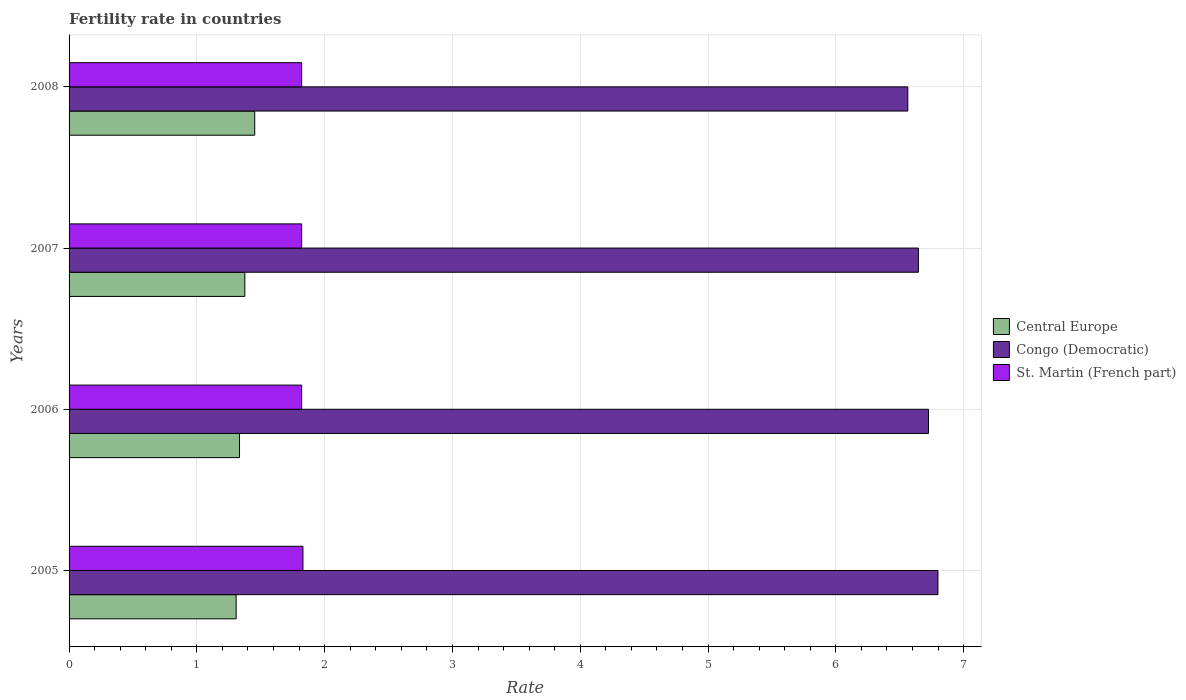How many different coloured bars are there?
Give a very brief answer. 3. How many groups of bars are there?
Provide a succinct answer. 4. Are the number of bars per tick equal to the number of legend labels?
Keep it short and to the point. Yes. How many bars are there on the 2nd tick from the top?
Offer a very short reply. 3. What is the label of the 3rd group of bars from the top?
Offer a terse response. 2006. What is the fertility rate in St. Martin (French part) in 2008?
Your answer should be compact. 1.82. Across all years, what is the maximum fertility rate in St. Martin (French part)?
Your answer should be very brief. 1.83. Across all years, what is the minimum fertility rate in St. Martin (French part)?
Your answer should be compact. 1.82. What is the total fertility rate in Central Europe in the graph?
Offer a very short reply. 5.47. What is the difference between the fertility rate in Congo (Democratic) in 2007 and that in 2008?
Ensure brevity in your answer.  0.08. What is the difference between the fertility rate in Central Europe in 2006 and the fertility rate in Congo (Democratic) in 2008?
Offer a terse response. -5.23. What is the average fertility rate in Congo (Democratic) per year?
Keep it short and to the point. 6.68. In the year 2006, what is the difference between the fertility rate in Congo (Democratic) and fertility rate in Central Europe?
Give a very brief answer. 5.39. In how many years, is the fertility rate in St. Martin (French part) greater than 0.2 ?
Offer a very short reply. 4. What is the difference between the highest and the second highest fertility rate in St. Martin (French part)?
Provide a short and direct response. 0.01. What is the difference between the highest and the lowest fertility rate in Congo (Democratic)?
Keep it short and to the point. 0.24. In how many years, is the fertility rate in Central Europe greater than the average fertility rate in Central Europe taken over all years?
Provide a succinct answer. 2. What does the 3rd bar from the top in 2007 represents?
Keep it short and to the point. Central Europe. What does the 3rd bar from the bottom in 2005 represents?
Your answer should be very brief. St. Martin (French part). Is it the case that in every year, the sum of the fertility rate in St. Martin (French part) and fertility rate in Central Europe is greater than the fertility rate in Congo (Democratic)?
Your answer should be very brief. No. How many bars are there?
Offer a very short reply. 12. How many years are there in the graph?
Give a very brief answer. 4. Where does the legend appear in the graph?
Provide a succinct answer. Center right. What is the title of the graph?
Give a very brief answer. Fertility rate in countries. What is the label or title of the X-axis?
Your answer should be very brief. Rate. What is the label or title of the Y-axis?
Make the answer very short. Years. What is the Rate in Central Europe in 2005?
Keep it short and to the point. 1.31. What is the Rate of Congo (Democratic) in 2005?
Provide a short and direct response. 6.8. What is the Rate of St. Martin (French part) in 2005?
Offer a very short reply. 1.83. What is the Rate in Central Europe in 2006?
Your answer should be compact. 1.33. What is the Rate of Congo (Democratic) in 2006?
Give a very brief answer. 6.72. What is the Rate of St. Martin (French part) in 2006?
Keep it short and to the point. 1.82. What is the Rate of Central Europe in 2007?
Give a very brief answer. 1.38. What is the Rate in Congo (Democratic) in 2007?
Offer a very short reply. 6.65. What is the Rate in St. Martin (French part) in 2007?
Give a very brief answer. 1.82. What is the Rate in Central Europe in 2008?
Your answer should be very brief. 1.45. What is the Rate in Congo (Democratic) in 2008?
Offer a terse response. 6.56. What is the Rate in St. Martin (French part) in 2008?
Your answer should be compact. 1.82. Across all years, what is the maximum Rate of Central Europe?
Ensure brevity in your answer.  1.45. Across all years, what is the maximum Rate in Congo (Democratic)?
Keep it short and to the point. 6.8. Across all years, what is the maximum Rate of St. Martin (French part)?
Your response must be concise. 1.83. Across all years, what is the minimum Rate in Central Europe?
Offer a very short reply. 1.31. Across all years, what is the minimum Rate in Congo (Democratic)?
Your answer should be compact. 6.56. Across all years, what is the minimum Rate of St. Martin (French part)?
Provide a short and direct response. 1.82. What is the total Rate of Central Europe in the graph?
Provide a succinct answer. 5.47. What is the total Rate in Congo (Democratic) in the graph?
Offer a very short reply. 26.73. What is the total Rate in St. Martin (French part) in the graph?
Provide a short and direct response. 7.29. What is the difference between the Rate of Central Europe in 2005 and that in 2006?
Your response must be concise. -0.03. What is the difference between the Rate of Congo (Democratic) in 2005 and that in 2006?
Your answer should be compact. 0.07. What is the difference between the Rate of St. Martin (French part) in 2005 and that in 2006?
Your answer should be very brief. 0.01. What is the difference between the Rate in Central Europe in 2005 and that in 2007?
Keep it short and to the point. -0.07. What is the difference between the Rate in Congo (Democratic) in 2005 and that in 2007?
Offer a very short reply. 0.15. What is the difference between the Rate in St. Martin (French part) in 2005 and that in 2007?
Provide a succinct answer. 0.01. What is the difference between the Rate in Central Europe in 2005 and that in 2008?
Offer a very short reply. -0.15. What is the difference between the Rate of Congo (Democratic) in 2005 and that in 2008?
Ensure brevity in your answer.  0.24. What is the difference between the Rate in St. Martin (French part) in 2005 and that in 2008?
Give a very brief answer. 0.01. What is the difference between the Rate of Central Europe in 2006 and that in 2007?
Keep it short and to the point. -0.04. What is the difference between the Rate in Congo (Democratic) in 2006 and that in 2007?
Your response must be concise. 0.08. What is the difference between the Rate of St. Martin (French part) in 2006 and that in 2007?
Your answer should be compact. 0. What is the difference between the Rate of Central Europe in 2006 and that in 2008?
Provide a short and direct response. -0.12. What is the difference between the Rate of Congo (Democratic) in 2006 and that in 2008?
Offer a very short reply. 0.16. What is the difference between the Rate in Central Europe in 2007 and that in 2008?
Give a very brief answer. -0.08. What is the difference between the Rate of Congo (Democratic) in 2007 and that in 2008?
Keep it short and to the point. 0.08. What is the difference between the Rate in Central Europe in 2005 and the Rate in Congo (Democratic) in 2006?
Keep it short and to the point. -5.42. What is the difference between the Rate in Central Europe in 2005 and the Rate in St. Martin (French part) in 2006?
Offer a very short reply. -0.51. What is the difference between the Rate of Congo (Democratic) in 2005 and the Rate of St. Martin (French part) in 2006?
Give a very brief answer. 4.98. What is the difference between the Rate in Central Europe in 2005 and the Rate in Congo (Democratic) in 2007?
Provide a succinct answer. -5.34. What is the difference between the Rate of Central Europe in 2005 and the Rate of St. Martin (French part) in 2007?
Keep it short and to the point. -0.51. What is the difference between the Rate of Congo (Democratic) in 2005 and the Rate of St. Martin (French part) in 2007?
Provide a short and direct response. 4.98. What is the difference between the Rate in Central Europe in 2005 and the Rate in Congo (Democratic) in 2008?
Provide a succinct answer. -5.26. What is the difference between the Rate in Central Europe in 2005 and the Rate in St. Martin (French part) in 2008?
Provide a succinct answer. -0.51. What is the difference between the Rate of Congo (Democratic) in 2005 and the Rate of St. Martin (French part) in 2008?
Your answer should be very brief. 4.98. What is the difference between the Rate of Central Europe in 2006 and the Rate of Congo (Democratic) in 2007?
Ensure brevity in your answer.  -5.31. What is the difference between the Rate of Central Europe in 2006 and the Rate of St. Martin (French part) in 2007?
Provide a succinct answer. -0.49. What is the difference between the Rate in Congo (Democratic) in 2006 and the Rate in St. Martin (French part) in 2007?
Your answer should be compact. 4.91. What is the difference between the Rate of Central Europe in 2006 and the Rate of Congo (Democratic) in 2008?
Offer a very short reply. -5.23. What is the difference between the Rate in Central Europe in 2006 and the Rate in St. Martin (French part) in 2008?
Provide a succinct answer. -0.49. What is the difference between the Rate of Congo (Democratic) in 2006 and the Rate of St. Martin (French part) in 2008?
Keep it short and to the point. 4.91. What is the difference between the Rate of Central Europe in 2007 and the Rate of Congo (Democratic) in 2008?
Ensure brevity in your answer.  -5.19. What is the difference between the Rate of Central Europe in 2007 and the Rate of St. Martin (French part) in 2008?
Provide a short and direct response. -0.44. What is the difference between the Rate of Congo (Democratic) in 2007 and the Rate of St. Martin (French part) in 2008?
Your answer should be compact. 4.83. What is the average Rate in Central Europe per year?
Give a very brief answer. 1.37. What is the average Rate in Congo (Democratic) per year?
Provide a short and direct response. 6.68. What is the average Rate of St. Martin (French part) per year?
Keep it short and to the point. 1.82. In the year 2005, what is the difference between the Rate in Central Europe and Rate in Congo (Democratic)?
Offer a terse response. -5.49. In the year 2005, what is the difference between the Rate in Central Europe and Rate in St. Martin (French part)?
Make the answer very short. -0.52. In the year 2005, what is the difference between the Rate in Congo (Democratic) and Rate in St. Martin (French part)?
Provide a short and direct response. 4.97. In the year 2006, what is the difference between the Rate of Central Europe and Rate of Congo (Democratic)?
Your answer should be compact. -5.39. In the year 2006, what is the difference between the Rate of Central Europe and Rate of St. Martin (French part)?
Offer a terse response. -0.49. In the year 2006, what is the difference between the Rate in Congo (Democratic) and Rate in St. Martin (French part)?
Your response must be concise. 4.91. In the year 2007, what is the difference between the Rate in Central Europe and Rate in Congo (Democratic)?
Provide a short and direct response. -5.27. In the year 2007, what is the difference between the Rate in Central Europe and Rate in St. Martin (French part)?
Offer a very short reply. -0.44. In the year 2007, what is the difference between the Rate in Congo (Democratic) and Rate in St. Martin (French part)?
Make the answer very short. 4.83. In the year 2008, what is the difference between the Rate of Central Europe and Rate of Congo (Democratic)?
Your answer should be compact. -5.11. In the year 2008, what is the difference between the Rate in Central Europe and Rate in St. Martin (French part)?
Make the answer very short. -0.37. In the year 2008, what is the difference between the Rate of Congo (Democratic) and Rate of St. Martin (French part)?
Provide a succinct answer. 4.74. What is the ratio of the Rate of Congo (Democratic) in 2005 to that in 2006?
Provide a succinct answer. 1.01. What is the ratio of the Rate of St. Martin (French part) in 2005 to that in 2006?
Your answer should be very brief. 1.01. What is the ratio of the Rate in Central Europe in 2005 to that in 2007?
Give a very brief answer. 0.95. What is the ratio of the Rate in St. Martin (French part) in 2005 to that in 2007?
Provide a short and direct response. 1.01. What is the ratio of the Rate in Central Europe in 2005 to that in 2008?
Your response must be concise. 0.9. What is the ratio of the Rate of Congo (Democratic) in 2005 to that in 2008?
Your answer should be very brief. 1.04. What is the ratio of the Rate in St. Martin (French part) in 2005 to that in 2008?
Provide a short and direct response. 1.01. What is the ratio of the Rate of Central Europe in 2006 to that in 2007?
Make the answer very short. 0.97. What is the ratio of the Rate of Congo (Democratic) in 2006 to that in 2007?
Provide a succinct answer. 1.01. What is the ratio of the Rate of St. Martin (French part) in 2006 to that in 2007?
Offer a terse response. 1. What is the ratio of the Rate in Central Europe in 2006 to that in 2008?
Make the answer very short. 0.92. What is the ratio of the Rate in Congo (Democratic) in 2006 to that in 2008?
Your answer should be very brief. 1.02. What is the ratio of the Rate of St. Martin (French part) in 2006 to that in 2008?
Make the answer very short. 1. What is the ratio of the Rate of Central Europe in 2007 to that in 2008?
Ensure brevity in your answer.  0.95. What is the ratio of the Rate in Congo (Democratic) in 2007 to that in 2008?
Provide a short and direct response. 1.01. What is the ratio of the Rate of St. Martin (French part) in 2007 to that in 2008?
Your answer should be very brief. 1. What is the difference between the highest and the second highest Rate of Central Europe?
Your response must be concise. 0.08. What is the difference between the highest and the second highest Rate in Congo (Democratic)?
Offer a terse response. 0.07. What is the difference between the highest and the lowest Rate in Central Europe?
Offer a terse response. 0.15. What is the difference between the highest and the lowest Rate of Congo (Democratic)?
Your answer should be very brief. 0.24. What is the difference between the highest and the lowest Rate in St. Martin (French part)?
Keep it short and to the point. 0.01. 